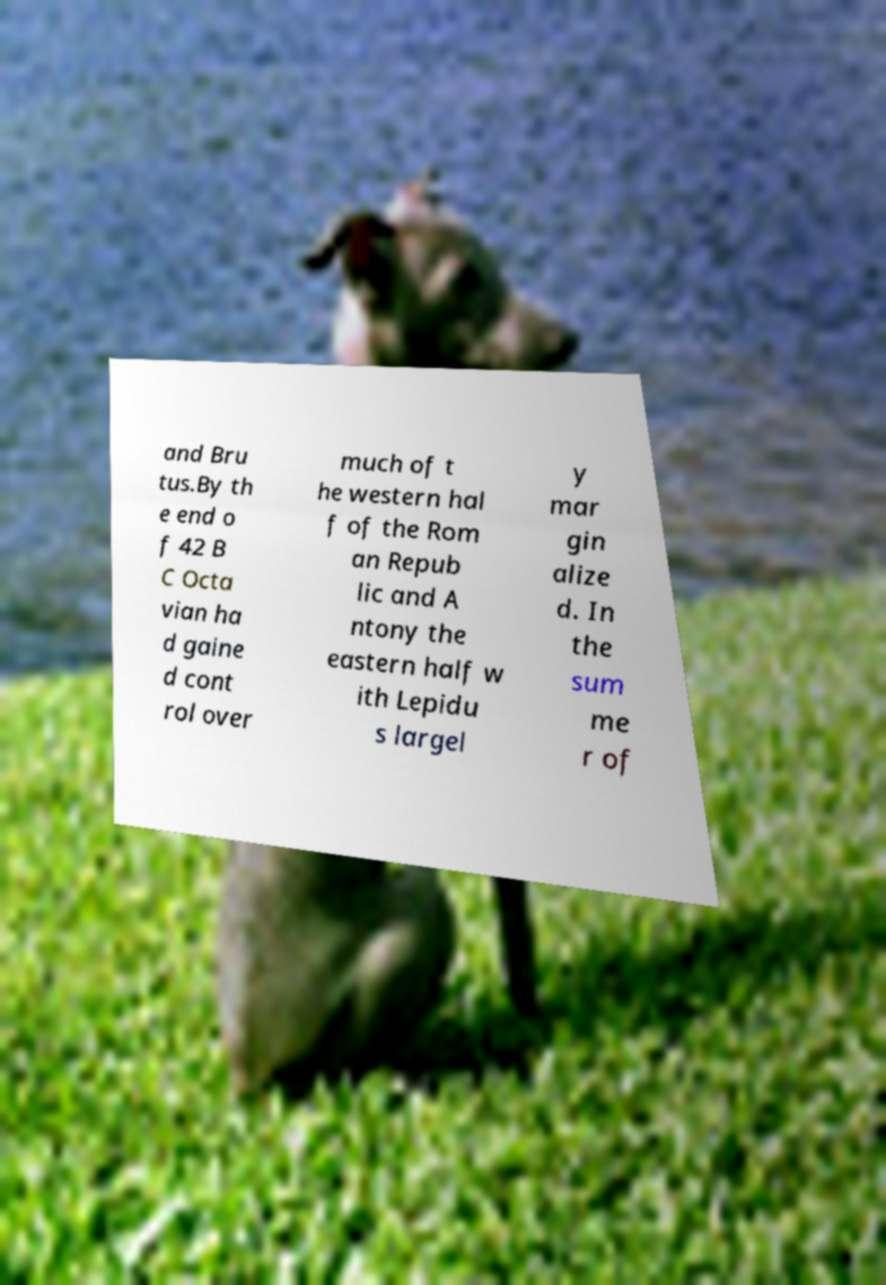What messages or text are displayed in this image? I need them in a readable, typed format. and Bru tus.By th e end o f 42 B C Octa vian ha d gaine d cont rol over much of t he western hal f of the Rom an Repub lic and A ntony the eastern half w ith Lepidu s largel y mar gin alize d. In the sum me r of 